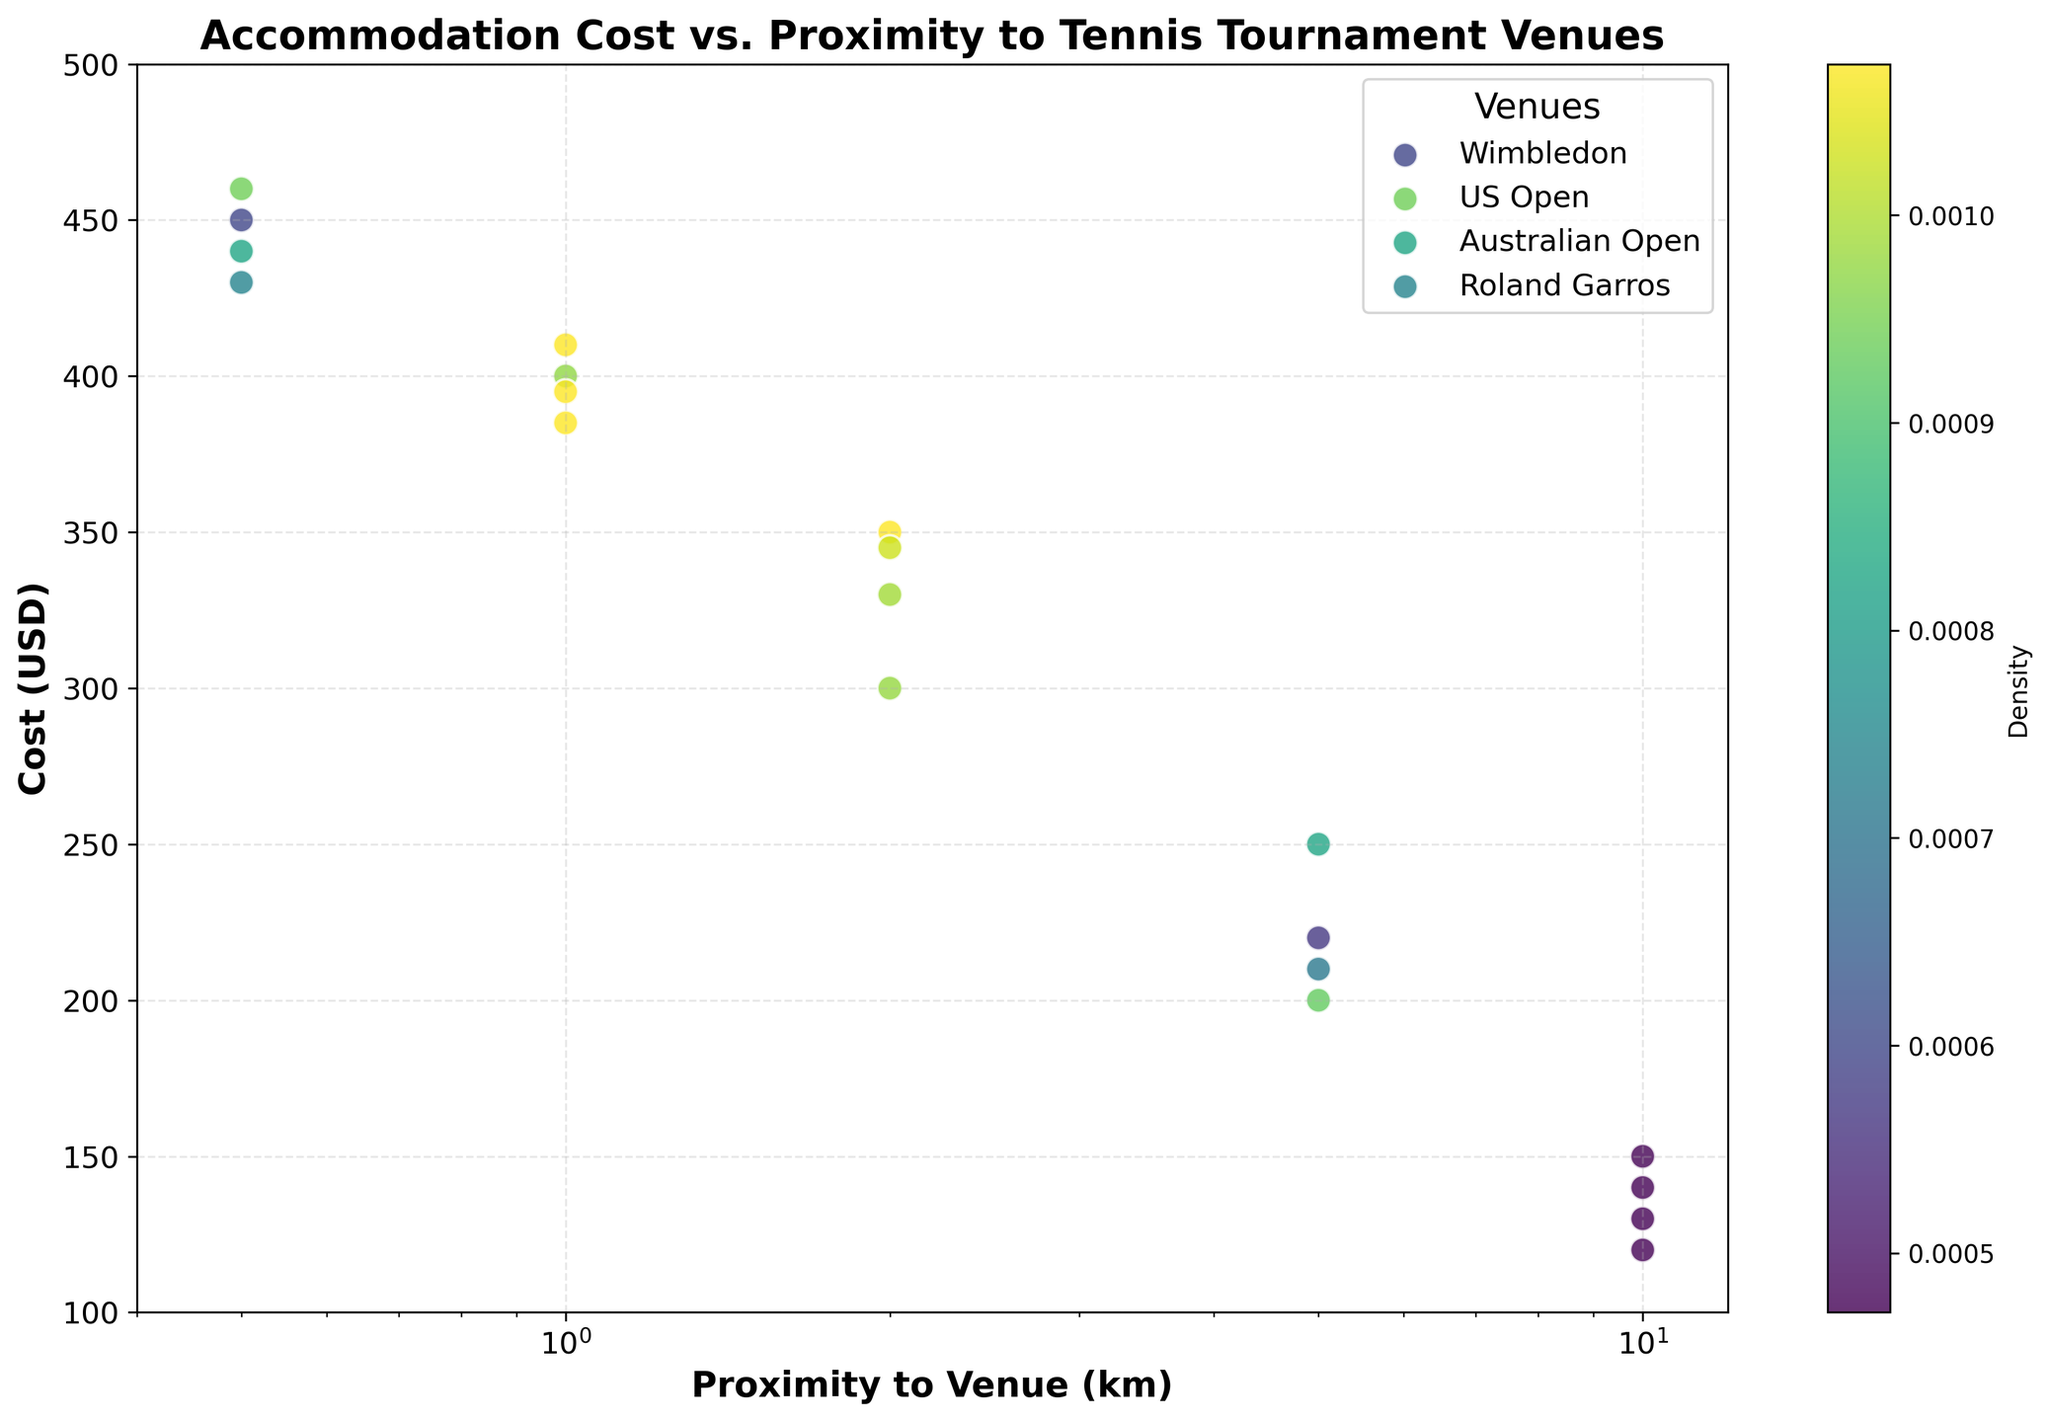What is the title of the plot? The title is usually at the top of the plot, and it helps viewers understand what the plot is about. The title here is clearly stated in a bold font.
Answer: Accommodation Cost vs. Proximity to Tennis Tournament Venues What are the units used on the x-axis? The x-axis label indicates the units used for measurement. Here, the label is 'Proximity to Venue (km)', so the units are kilometers (km).
Answer: Kilometers (km) Which venue is the most represented in terms of data points? Each venue has the same number of data points. By counting the points (or number of labels in the legend), we can see that each venue has five data points.
Answer: All venues are equally represented Which venue has the highest accommodation cost at 0.5 km proximity? Looking at the plot, the highest point at 0.5 km can be identified by comparing the y-values for each of the venues at this proximity.
Answer: US Open How does the accommodation cost change with increasing distance from the venue? Observe the trend of data points for each venue. As the distance increases (moving right on the x-axis), the cost generally decreases (y-values go down).
Answer: Costs decrease as distance increases At what distance do the accommodation costs drop below $200 for all venues? Check the y-values for each venue and find the distance at which all of them are below the $200 mark. This is visible where all the data points fall below the horizontal line at $200.
Answer: 5 km Which venue has the least dense (sparsest) accommodation costs, and at what distances? The density can be inferred by looking at the color intensity associated with the scatter points. Less dense regions are seen with lighter colors.
Answer: Roland Garros, especially at 1 km and 2 km Is there a significant difference in cost between accommodations at 0.5 km and 1 km for any venue? Compare the costs (y-values) for each venue between 0.5 km and 1 km proximity. A significant difference will be a large vertical gap between the points.
Answer: The difference is more pronounced for US Open Which venue shows the least cost variation as proximity increases up to 10 km? Look at the spread of the data points for each venue along the y-axis as the x-axis extends from 0.5 km to 10 km. The venue with smaller vertical spread has the least cost variation.
Answer: Australian Open 